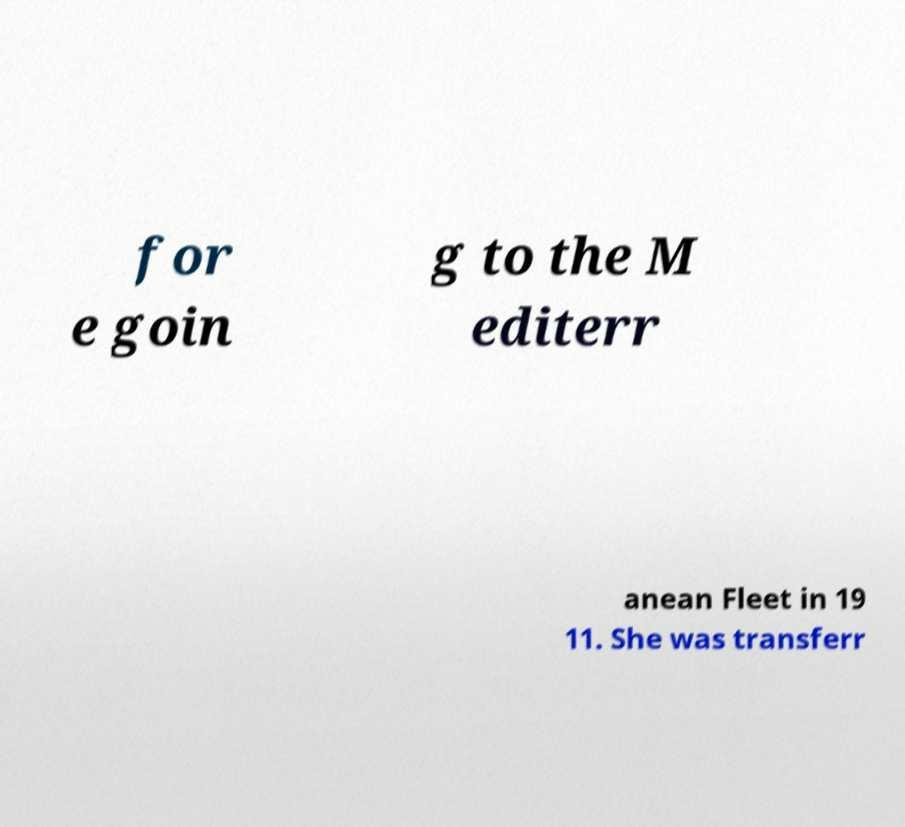Could you assist in decoding the text presented in this image and type it out clearly? for e goin g to the M editerr anean Fleet in 19 11. She was transferr 